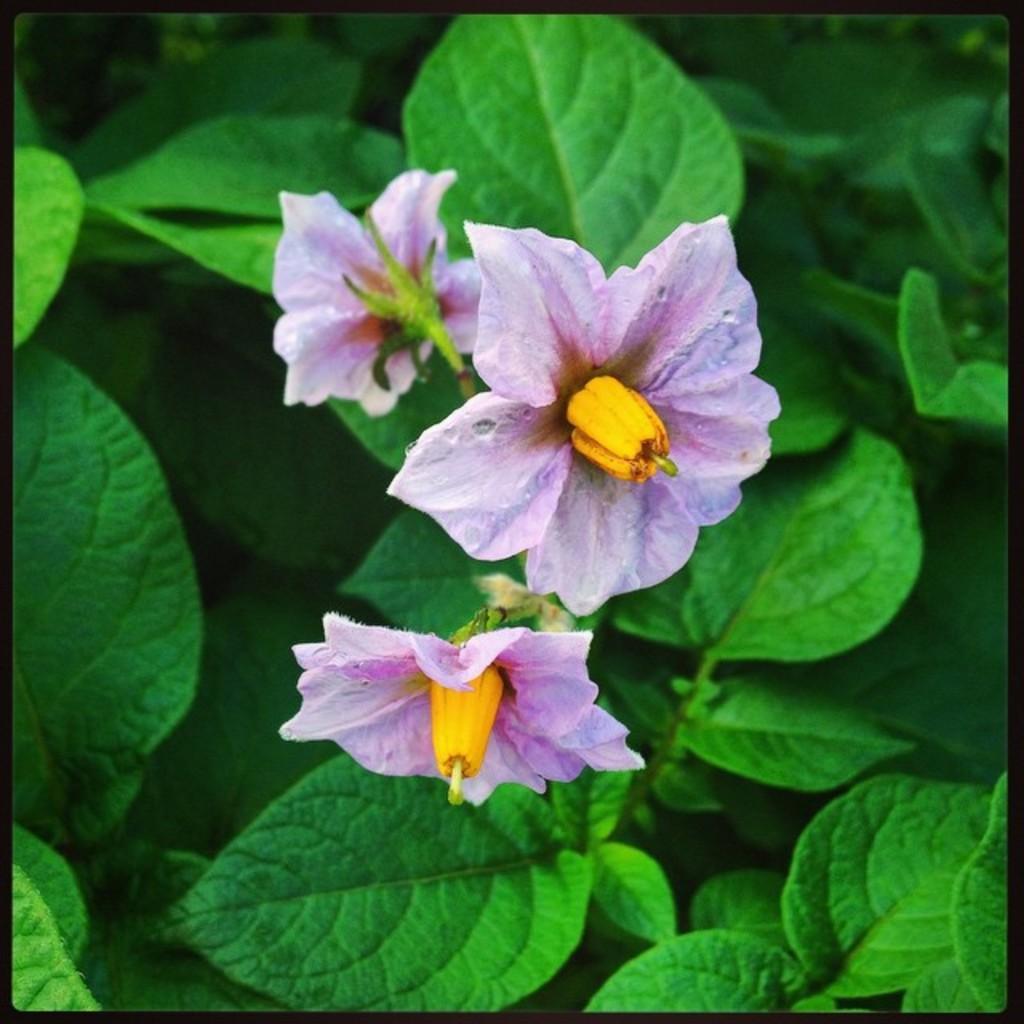Could you give a brief overview of what you see in this image? This image consists of flowers along with green leaves. 